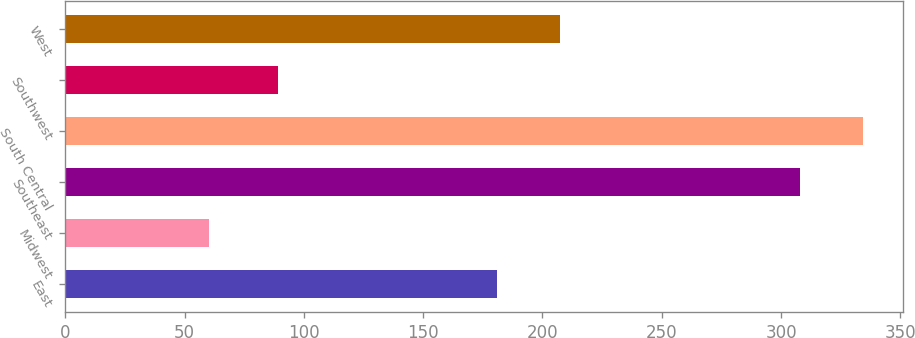<chart> <loc_0><loc_0><loc_500><loc_500><bar_chart><fcel>East<fcel>Midwest<fcel>Southeast<fcel>South Central<fcel>Southwest<fcel>West<nl><fcel>181<fcel>60<fcel>308<fcel>334.4<fcel>89<fcel>207.4<nl></chart> 